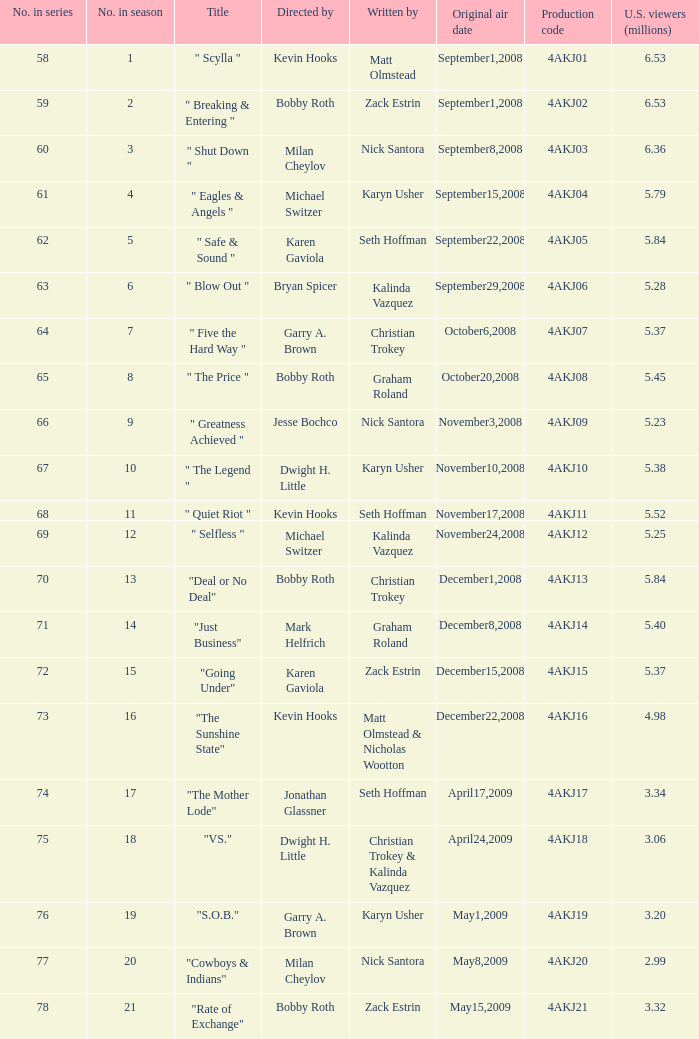Who was in charge of directing the episode that carried the production code 4akj01? Kevin Hooks. 